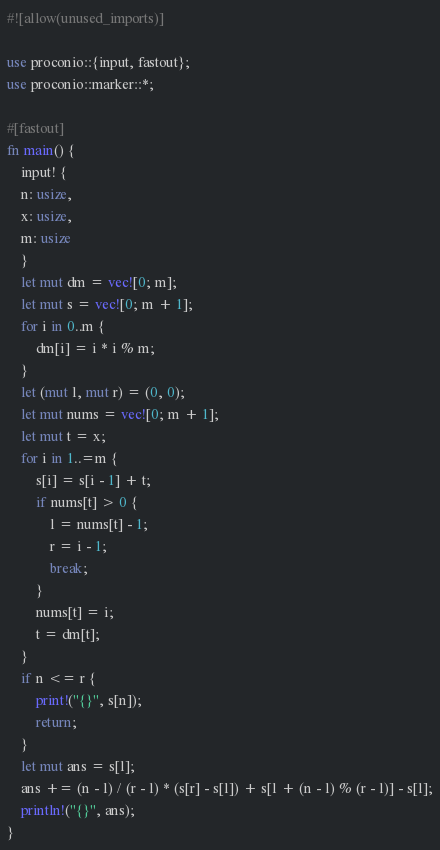Convert code to text. <code><loc_0><loc_0><loc_500><loc_500><_Rust_>#![allow(unused_imports)]

use proconio::{input, fastout};
use proconio::marker::*;

#[fastout]
fn main() {
    input! {
    n: usize,
    x: usize,
    m: usize
    }
    let mut dm = vec![0; m];
    let mut s = vec![0; m + 1];
    for i in 0..m {
        dm[i] = i * i % m;
    }
    let (mut l, mut r) = (0, 0);
    let mut nums = vec![0; m + 1];
    let mut t = x;
    for i in 1..=m {
        s[i] = s[i - 1] + t;
        if nums[t] > 0 {
            l = nums[t] - 1;
            r = i - 1;
            break;
        }
        nums[t] = i;
        t = dm[t];
    }
    if n <= r {
        print!("{}", s[n]);
        return;
    }
    let mut ans = s[l];
    ans += (n - l) / (r - l) * (s[r] - s[l]) + s[l + (n - l) % (r - l)] - s[l];
    println!("{}", ans);
}
</code> 